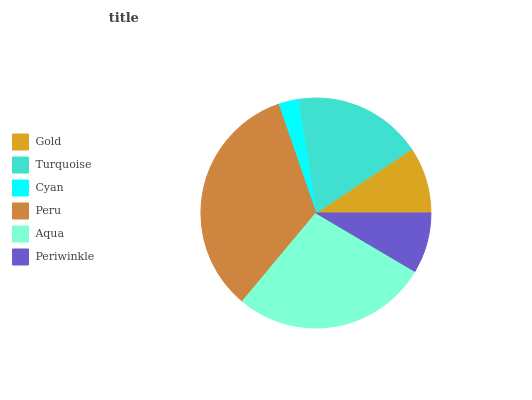Is Cyan the minimum?
Answer yes or no. Yes. Is Peru the maximum?
Answer yes or no. Yes. Is Turquoise the minimum?
Answer yes or no. No. Is Turquoise the maximum?
Answer yes or no. No. Is Turquoise greater than Gold?
Answer yes or no. Yes. Is Gold less than Turquoise?
Answer yes or no. Yes. Is Gold greater than Turquoise?
Answer yes or no. No. Is Turquoise less than Gold?
Answer yes or no. No. Is Turquoise the high median?
Answer yes or no. Yes. Is Gold the low median?
Answer yes or no. Yes. Is Periwinkle the high median?
Answer yes or no. No. Is Cyan the low median?
Answer yes or no. No. 